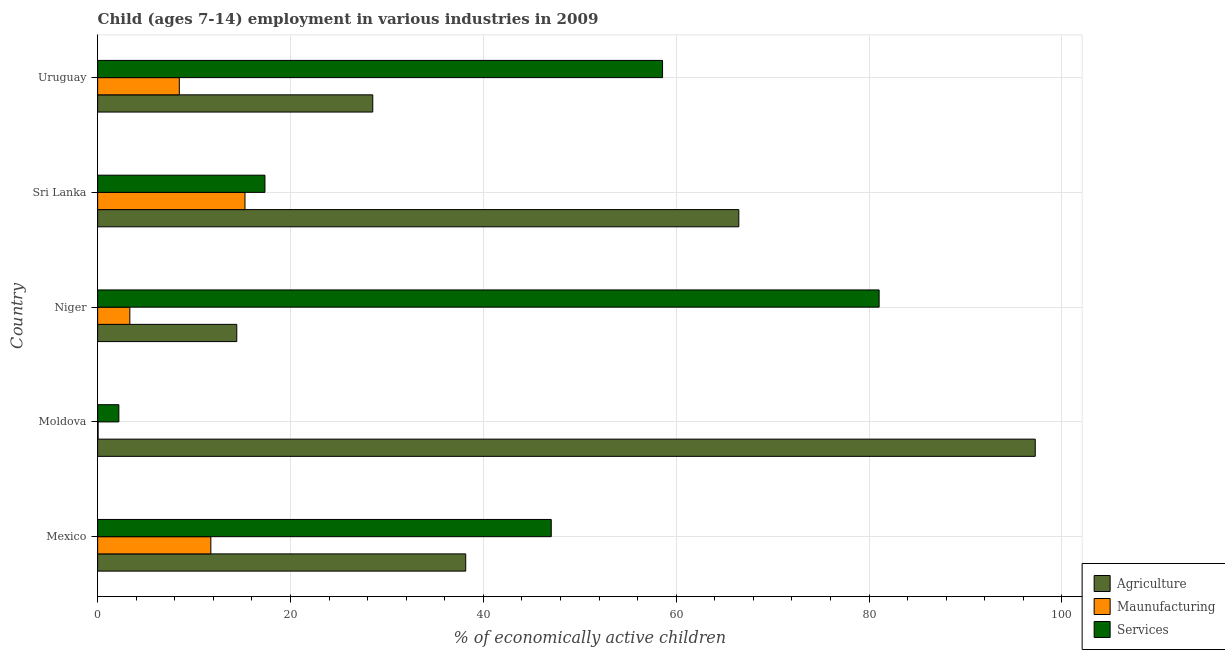How many different coloured bars are there?
Your response must be concise. 3. How many groups of bars are there?
Provide a succinct answer. 5. Are the number of bars on each tick of the Y-axis equal?
Your answer should be very brief. Yes. How many bars are there on the 1st tick from the top?
Your response must be concise. 3. How many bars are there on the 2nd tick from the bottom?
Your answer should be compact. 3. What is the label of the 2nd group of bars from the top?
Your answer should be very brief. Sri Lanka. In how many cases, is the number of bars for a given country not equal to the number of legend labels?
Make the answer very short. 0. What is the percentage of economically active children in services in Niger?
Make the answer very short. 81.04. Across all countries, what is the maximum percentage of economically active children in agriculture?
Keep it short and to the point. 97.23. Across all countries, what is the minimum percentage of economically active children in services?
Offer a very short reply. 2.2. In which country was the percentage of economically active children in agriculture maximum?
Give a very brief answer. Moldova. In which country was the percentage of economically active children in services minimum?
Your answer should be very brief. Moldova. What is the total percentage of economically active children in agriculture in the graph?
Your response must be concise. 244.85. What is the difference between the percentage of economically active children in manufacturing in Mexico and that in Sri Lanka?
Make the answer very short. -3.54. What is the difference between the percentage of economically active children in agriculture in Moldova and the percentage of economically active children in manufacturing in Mexico?
Provide a short and direct response. 85.49. What is the average percentage of economically active children in agriculture per country?
Provide a succinct answer. 48.97. What is the difference between the percentage of economically active children in services and percentage of economically active children in manufacturing in Uruguay?
Give a very brief answer. 50.11. What is the ratio of the percentage of economically active children in manufacturing in Moldova to that in Niger?
Keep it short and to the point. 0.01. Is the percentage of economically active children in services in Mexico less than that in Moldova?
Your response must be concise. No. What is the difference between the highest and the second highest percentage of economically active children in services?
Offer a terse response. 22.46. What is the difference between the highest and the lowest percentage of economically active children in manufacturing?
Provide a succinct answer. 15.23. In how many countries, is the percentage of economically active children in manufacturing greater than the average percentage of economically active children in manufacturing taken over all countries?
Ensure brevity in your answer.  3. What does the 2nd bar from the top in Niger represents?
Your answer should be compact. Maunufacturing. What does the 1st bar from the bottom in Uruguay represents?
Provide a short and direct response. Agriculture. How many countries are there in the graph?
Provide a succinct answer. 5. What is the difference between two consecutive major ticks on the X-axis?
Your answer should be very brief. 20. Does the graph contain any zero values?
Provide a short and direct response. No. Does the graph contain grids?
Provide a short and direct response. Yes. Where does the legend appear in the graph?
Make the answer very short. Bottom right. How many legend labels are there?
Give a very brief answer. 3. What is the title of the graph?
Offer a very short reply. Child (ages 7-14) employment in various industries in 2009. What is the label or title of the X-axis?
Ensure brevity in your answer.  % of economically active children. What is the label or title of the Y-axis?
Give a very brief answer. Country. What is the % of economically active children in Agriculture in Mexico?
Keep it short and to the point. 38.17. What is the % of economically active children in Maunufacturing in Mexico?
Offer a very short reply. 11.74. What is the % of economically active children in Services in Mexico?
Give a very brief answer. 47.04. What is the % of economically active children in Agriculture in Moldova?
Give a very brief answer. 97.23. What is the % of economically active children of Maunufacturing in Moldova?
Your response must be concise. 0.05. What is the % of economically active children in Services in Moldova?
Your answer should be compact. 2.2. What is the % of economically active children of Agriculture in Niger?
Keep it short and to the point. 14.43. What is the % of economically active children in Maunufacturing in Niger?
Make the answer very short. 3.34. What is the % of economically active children of Services in Niger?
Keep it short and to the point. 81.04. What is the % of economically active children in Agriculture in Sri Lanka?
Offer a terse response. 66.49. What is the % of economically active children of Maunufacturing in Sri Lanka?
Make the answer very short. 15.28. What is the % of economically active children in Services in Sri Lanka?
Your answer should be compact. 17.35. What is the % of economically active children in Agriculture in Uruguay?
Your answer should be very brief. 28.53. What is the % of economically active children in Maunufacturing in Uruguay?
Keep it short and to the point. 8.47. What is the % of economically active children of Services in Uruguay?
Your answer should be compact. 58.58. Across all countries, what is the maximum % of economically active children of Agriculture?
Offer a terse response. 97.23. Across all countries, what is the maximum % of economically active children in Maunufacturing?
Give a very brief answer. 15.28. Across all countries, what is the maximum % of economically active children of Services?
Your response must be concise. 81.04. Across all countries, what is the minimum % of economically active children of Agriculture?
Ensure brevity in your answer.  14.43. Across all countries, what is the minimum % of economically active children of Maunufacturing?
Your answer should be compact. 0.05. What is the total % of economically active children in Agriculture in the graph?
Your response must be concise. 244.85. What is the total % of economically active children of Maunufacturing in the graph?
Ensure brevity in your answer.  38.88. What is the total % of economically active children of Services in the graph?
Your response must be concise. 206.21. What is the difference between the % of economically active children of Agriculture in Mexico and that in Moldova?
Your response must be concise. -59.06. What is the difference between the % of economically active children in Maunufacturing in Mexico and that in Moldova?
Offer a very short reply. 11.69. What is the difference between the % of economically active children of Services in Mexico and that in Moldova?
Give a very brief answer. 44.84. What is the difference between the % of economically active children in Agriculture in Mexico and that in Niger?
Provide a short and direct response. 23.74. What is the difference between the % of economically active children of Maunufacturing in Mexico and that in Niger?
Make the answer very short. 8.4. What is the difference between the % of economically active children in Services in Mexico and that in Niger?
Make the answer very short. -34. What is the difference between the % of economically active children of Agriculture in Mexico and that in Sri Lanka?
Provide a succinct answer. -28.32. What is the difference between the % of economically active children of Maunufacturing in Mexico and that in Sri Lanka?
Give a very brief answer. -3.54. What is the difference between the % of economically active children in Services in Mexico and that in Sri Lanka?
Keep it short and to the point. 29.69. What is the difference between the % of economically active children of Agriculture in Mexico and that in Uruguay?
Give a very brief answer. 9.64. What is the difference between the % of economically active children of Maunufacturing in Mexico and that in Uruguay?
Ensure brevity in your answer.  3.27. What is the difference between the % of economically active children of Services in Mexico and that in Uruguay?
Provide a succinct answer. -11.54. What is the difference between the % of economically active children of Agriculture in Moldova and that in Niger?
Your answer should be compact. 82.8. What is the difference between the % of economically active children in Maunufacturing in Moldova and that in Niger?
Offer a terse response. -3.29. What is the difference between the % of economically active children in Services in Moldova and that in Niger?
Your response must be concise. -78.84. What is the difference between the % of economically active children of Agriculture in Moldova and that in Sri Lanka?
Provide a short and direct response. 30.74. What is the difference between the % of economically active children in Maunufacturing in Moldova and that in Sri Lanka?
Your answer should be very brief. -15.23. What is the difference between the % of economically active children of Services in Moldova and that in Sri Lanka?
Provide a short and direct response. -15.15. What is the difference between the % of economically active children of Agriculture in Moldova and that in Uruguay?
Ensure brevity in your answer.  68.7. What is the difference between the % of economically active children of Maunufacturing in Moldova and that in Uruguay?
Offer a very short reply. -8.42. What is the difference between the % of economically active children in Services in Moldova and that in Uruguay?
Give a very brief answer. -56.38. What is the difference between the % of economically active children of Agriculture in Niger and that in Sri Lanka?
Offer a terse response. -52.06. What is the difference between the % of economically active children in Maunufacturing in Niger and that in Sri Lanka?
Offer a terse response. -11.94. What is the difference between the % of economically active children in Services in Niger and that in Sri Lanka?
Offer a very short reply. 63.69. What is the difference between the % of economically active children in Agriculture in Niger and that in Uruguay?
Your answer should be compact. -14.1. What is the difference between the % of economically active children of Maunufacturing in Niger and that in Uruguay?
Offer a terse response. -5.13. What is the difference between the % of economically active children in Services in Niger and that in Uruguay?
Make the answer very short. 22.46. What is the difference between the % of economically active children of Agriculture in Sri Lanka and that in Uruguay?
Your answer should be very brief. 37.96. What is the difference between the % of economically active children in Maunufacturing in Sri Lanka and that in Uruguay?
Provide a succinct answer. 6.81. What is the difference between the % of economically active children in Services in Sri Lanka and that in Uruguay?
Give a very brief answer. -41.23. What is the difference between the % of economically active children of Agriculture in Mexico and the % of economically active children of Maunufacturing in Moldova?
Provide a succinct answer. 38.12. What is the difference between the % of economically active children of Agriculture in Mexico and the % of economically active children of Services in Moldova?
Provide a succinct answer. 35.97. What is the difference between the % of economically active children in Maunufacturing in Mexico and the % of economically active children in Services in Moldova?
Ensure brevity in your answer.  9.54. What is the difference between the % of economically active children of Agriculture in Mexico and the % of economically active children of Maunufacturing in Niger?
Your answer should be very brief. 34.83. What is the difference between the % of economically active children in Agriculture in Mexico and the % of economically active children in Services in Niger?
Offer a terse response. -42.87. What is the difference between the % of economically active children of Maunufacturing in Mexico and the % of economically active children of Services in Niger?
Your response must be concise. -69.3. What is the difference between the % of economically active children of Agriculture in Mexico and the % of economically active children of Maunufacturing in Sri Lanka?
Your answer should be very brief. 22.89. What is the difference between the % of economically active children of Agriculture in Mexico and the % of economically active children of Services in Sri Lanka?
Your answer should be very brief. 20.82. What is the difference between the % of economically active children of Maunufacturing in Mexico and the % of economically active children of Services in Sri Lanka?
Keep it short and to the point. -5.61. What is the difference between the % of economically active children of Agriculture in Mexico and the % of economically active children of Maunufacturing in Uruguay?
Ensure brevity in your answer.  29.7. What is the difference between the % of economically active children of Agriculture in Mexico and the % of economically active children of Services in Uruguay?
Make the answer very short. -20.41. What is the difference between the % of economically active children in Maunufacturing in Mexico and the % of economically active children in Services in Uruguay?
Offer a very short reply. -46.84. What is the difference between the % of economically active children of Agriculture in Moldova and the % of economically active children of Maunufacturing in Niger?
Make the answer very short. 93.89. What is the difference between the % of economically active children of Agriculture in Moldova and the % of economically active children of Services in Niger?
Make the answer very short. 16.19. What is the difference between the % of economically active children in Maunufacturing in Moldova and the % of economically active children in Services in Niger?
Your answer should be compact. -80.99. What is the difference between the % of economically active children of Agriculture in Moldova and the % of economically active children of Maunufacturing in Sri Lanka?
Make the answer very short. 81.95. What is the difference between the % of economically active children of Agriculture in Moldova and the % of economically active children of Services in Sri Lanka?
Your answer should be very brief. 79.88. What is the difference between the % of economically active children of Maunufacturing in Moldova and the % of economically active children of Services in Sri Lanka?
Give a very brief answer. -17.3. What is the difference between the % of economically active children in Agriculture in Moldova and the % of economically active children in Maunufacturing in Uruguay?
Provide a short and direct response. 88.76. What is the difference between the % of economically active children of Agriculture in Moldova and the % of economically active children of Services in Uruguay?
Offer a very short reply. 38.65. What is the difference between the % of economically active children in Maunufacturing in Moldova and the % of economically active children in Services in Uruguay?
Your response must be concise. -58.53. What is the difference between the % of economically active children in Agriculture in Niger and the % of economically active children in Maunufacturing in Sri Lanka?
Give a very brief answer. -0.85. What is the difference between the % of economically active children in Agriculture in Niger and the % of economically active children in Services in Sri Lanka?
Offer a terse response. -2.92. What is the difference between the % of economically active children in Maunufacturing in Niger and the % of economically active children in Services in Sri Lanka?
Make the answer very short. -14.01. What is the difference between the % of economically active children in Agriculture in Niger and the % of economically active children in Maunufacturing in Uruguay?
Offer a terse response. 5.96. What is the difference between the % of economically active children in Agriculture in Niger and the % of economically active children in Services in Uruguay?
Provide a succinct answer. -44.15. What is the difference between the % of economically active children in Maunufacturing in Niger and the % of economically active children in Services in Uruguay?
Your answer should be compact. -55.24. What is the difference between the % of economically active children of Agriculture in Sri Lanka and the % of economically active children of Maunufacturing in Uruguay?
Your response must be concise. 58.02. What is the difference between the % of economically active children of Agriculture in Sri Lanka and the % of economically active children of Services in Uruguay?
Offer a terse response. 7.91. What is the difference between the % of economically active children of Maunufacturing in Sri Lanka and the % of economically active children of Services in Uruguay?
Offer a terse response. -43.3. What is the average % of economically active children of Agriculture per country?
Give a very brief answer. 48.97. What is the average % of economically active children in Maunufacturing per country?
Provide a short and direct response. 7.78. What is the average % of economically active children in Services per country?
Offer a very short reply. 41.24. What is the difference between the % of economically active children of Agriculture and % of economically active children of Maunufacturing in Mexico?
Keep it short and to the point. 26.43. What is the difference between the % of economically active children of Agriculture and % of economically active children of Services in Mexico?
Provide a succinct answer. -8.87. What is the difference between the % of economically active children of Maunufacturing and % of economically active children of Services in Mexico?
Your answer should be very brief. -35.3. What is the difference between the % of economically active children in Agriculture and % of economically active children in Maunufacturing in Moldova?
Your response must be concise. 97.18. What is the difference between the % of economically active children in Agriculture and % of economically active children in Services in Moldova?
Provide a short and direct response. 95.03. What is the difference between the % of economically active children in Maunufacturing and % of economically active children in Services in Moldova?
Keep it short and to the point. -2.15. What is the difference between the % of economically active children of Agriculture and % of economically active children of Maunufacturing in Niger?
Offer a terse response. 11.09. What is the difference between the % of economically active children in Agriculture and % of economically active children in Services in Niger?
Offer a terse response. -66.61. What is the difference between the % of economically active children of Maunufacturing and % of economically active children of Services in Niger?
Make the answer very short. -77.7. What is the difference between the % of economically active children in Agriculture and % of economically active children in Maunufacturing in Sri Lanka?
Your answer should be very brief. 51.21. What is the difference between the % of economically active children in Agriculture and % of economically active children in Services in Sri Lanka?
Give a very brief answer. 49.14. What is the difference between the % of economically active children in Maunufacturing and % of economically active children in Services in Sri Lanka?
Give a very brief answer. -2.07. What is the difference between the % of economically active children of Agriculture and % of economically active children of Maunufacturing in Uruguay?
Give a very brief answer. 20.06. What is the difference between the % of economically active children in Agriculture and % of economically active children in Services in Uruguay?
Provide a succinct answer. -30.05. What is the difference between the % of economically active children of Maunufacturing and % of economically active children of Services in Uruguay?
Keep it short and to the point. -50.11. What is the ratio of the % of economically active children of Agriculture in Mexico to that in Moldova?
Your response must be concise. 0.39. What is the ratio of the % of economically active children in Maunufacturing in Mexico to that in Moldova?
Provide a succinct answer. 234.8. What is the ratio of the % of economically active children of Services in Mexico to that in Moldova?
Provide a short and direct response. 21.38. What is the ratio of the % of economically active children in Agriculture in Mexico to that in Niger?
Your answer should be very brief. 2.65. What is the ratio of the % of economically active children of Maunufacturing in Mexico to that in Niger?
Your response must be concise. 3.52. What is the ratio of the % of economically active children in Services in Mexico to that in Niger?
Your answer should be very brief. 0.58. What is the ratio of the % of economically active children of Agriculture in Mexico to that in Sri Lanka?
Make the answer very short. 0.57. What is the ratio of the % of economically active children of Maunufacturing in Mexico to that in Sri Lanka?
Give a very brief answer. 0.77. What is the ratio of the % of economically active children of Services in Mexico to that in Sri Lanka?
Give a very brief answer. 2.71. What is the ratio of the % of economically active children in Agriculture in Mexico to that in Uruguay?
Your response must be concise. 1.34. What is the ratio of the % of economically active children of Maunufacturing in Mexico to that in Uruguay?
Your answer should be compact. 1.39. What is the ratio of the % of economically active children of Services in Mexico to that in Uruguay?
Keep it short and to the point. 0.8. What is the ratio of the % of economically active children of Agriculture in Moldova to that in Niger?
Provide a short and direct response. 6.74. What is the ratio of the % of economically active children of Maunufacturing in Moldova to that in Niger?
Your response must be concise. 0.01. What is the ratio of the % of economically active children of Services in Moldova to that in Niger?
Provide a succinct answer. 0.03. What is the ratio of the % of economically active children in Agriculture in Moldova to that in Sri Lanka?
Keep it short and to the point. 1.46. What is the ratio of the % of economically active children in Maunufacturing in Moldova to that in Sri Lanka?
Provide a short and direct response. 0. What is the ratio of the % of economically active children in Services in Moldova to that in Sri Lanka?
Keep it short and to the point. 0.13. What is the ratio of the % of economically active children in Agriculture in Moldova to that in Uruguay?
Offer a very short reply. 3.41. What is the ratio of the % of economically active children in Maunufacturing in Moldova to that in Uruguay?
Ensure brevity in your answer.  0.01. What is the ratio of the % of economically active children of Services in Moldova to that in Uruguay?
Offer a very short reply. 0.04. What is the ratio of the % of economically active children of Agriculture in Niger to that in Sri Lanka?
Provide a succinct answer. 0.22. What is the ratio of the % of economically active children in Maunufacturing in Niger to that in Sri Lanka?
Provide a succinct answer. 0.22. What is the ratio of the % of economically active children in Services in Niger to that in Sri Lanka?
Offer a very short reply. 4.67. What is the ratio of the % of economically active children of Agriculture in Niger to that in Uruguay?
Offer a very short reply. 0.51. What is the ratio of the % of economically active children in Maunufacturing in Niger to that in Uruguay?
Provide a short and direct response. 0.39. What is the ratio of the % of economically active children of Services in Niger to that in Uruguay?
Offer a terse response. 1.38. What is the ratio of the % of economically active children of Agriculture in Sri Lanka to that in Uruguay?
Provide a short and direct response. 2.33. What is the ratio of the % of economically active children of Maunufacturing in Sri Lanka to that in Uruguay?
Ensure brevity in your answer.  1.8. What is the ratio of the % of economically active children in Services in Sri Lanka to that in Uruguay?
Your answer should be very brief. 0.3. What is the difference between the highest and the second highest % of economically active children in Agriculture?
Provide a short and direct response. 30.74. What is the difference between the highest and the second highest % of economically active children of Maunufacturing?
Your answer should be compact. 3.54. What is the difference between the highest and the second highest % of economically active children of Services?
Your answer should be compact. 22.46. What is the difference between the highest and the lowest % of economically active children of Agriculture?
Keep it short and to the point. 82.8. What is the difference between the highest and the lowest % of economically active children of Maunufacturing?
Keep it short and to the point. 15.23. What is the difference between the highest and the lowest % of economically active children of Services?
Your response must be concise. 78.84. 